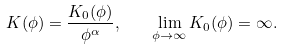Convert formula to latex. <formula><loc_0><loc_0><loc_500><loc_500>K ( \phi ) = \frac { K _ { 0 } ( \phi ) } { \phi ^ { \alpha } } , \quad \lim _ { \phi \rightarrow \infty } K _ { 0 } ( \phi ) = \infty .</formula> 